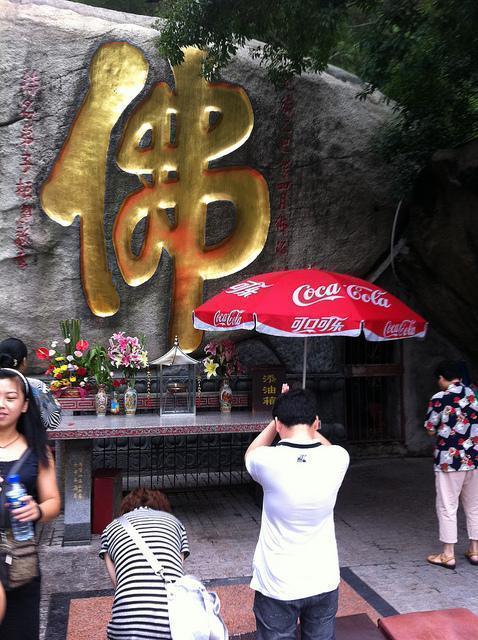What Pantone is Coca Cola red?
Choose the right answer from the provided options to respond to the question.
Options: Pms484, pms492, pms112, pms452. Pms484. 